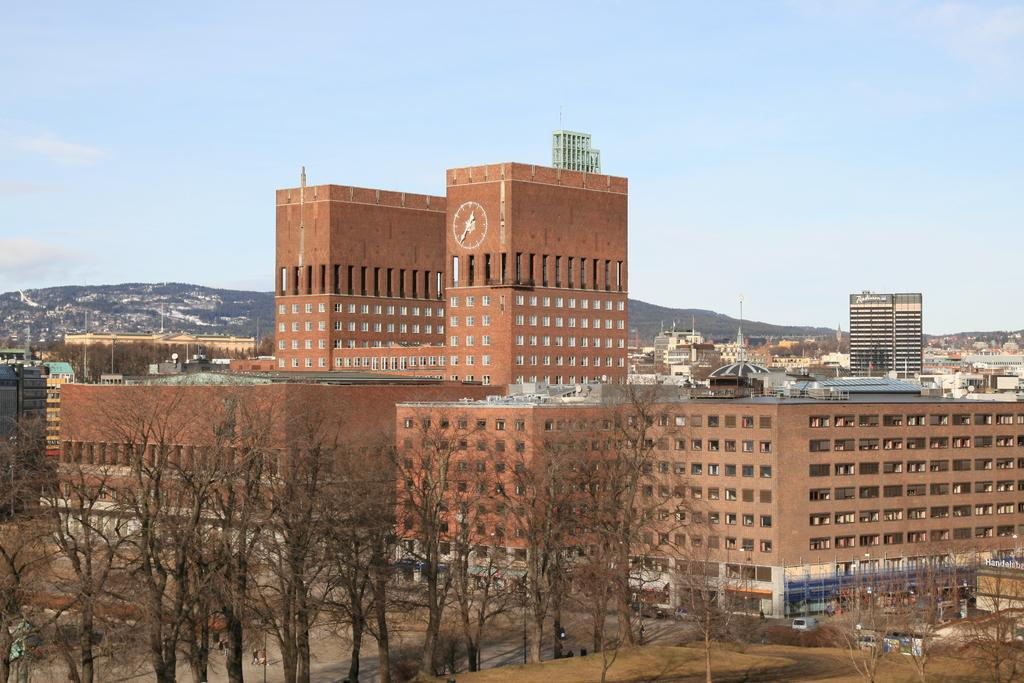What type of structures can be seen in the image? There are many buildings in the image. What other natural elements are present in the image? There are trees in the image. What mode of transportation can be seen on the road in the image? There are vehicles on the road in the image. What geographical features can be observed in the background of the image? There are hills visible in the image. Can you tell me how many people are swimming in the middle of the image? There is no swimming or people visible in the image; it features buildings, trees, vehicles, and hills. What type of crack is present in the image? There is no crack present in the image. 